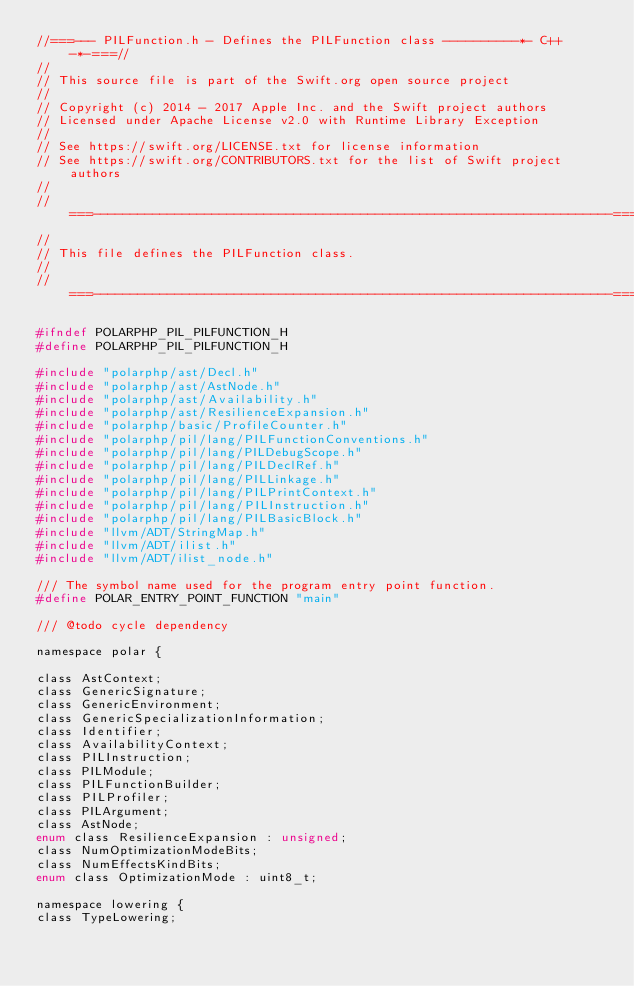<code> <loc_0><loc_0><loc_500><loc_500><_C_>//===--- PILFunction.h - Defines the PILFunction class ----------*- C++ -*-===//
//
// This source file is part of the Swift.org open source project
//
// Copyright (c) 2014 - 2017 Apple Inc. and the Swift project authors
// Licensed under Apache License v2.0 with Runtime Library Exception
//
// See https://swift.org/LICENSE.txt for license information
// See https://swift.org/CONTRIBUTORS.txt for the list of Swift project authors
//
//===----------------------------------------------------------------------===//
//
// This file defines the PILFunction class.
//
//===----------------------------------------------------------------------===//

#ifndef POLARPHP_PIL_PILFUNCTION_H
#define POLARPHP_PIL_PILFUNCTION_H

#include "polarphp/ast/Decl.h"
#include "polarphp/ast/AstNode.h"
#include "polarphp/ast/Availability.h"
#include "polarphp/ast/ResilienceExpansion.h"
#include "polarphp/basic/ProfileCounter.h"
#include "polarphp/pil/lang/PILFunctionConventions.h"
#include "polarphp/pil/lang/PILDebugScope.h"
#include "polarphp/pil/lang/PILDeclRef.h"
#include "polarphp/pil/lang/PILLinkage.h"
#include "polarphp/pil/lang/PILPrintContext.h"
#include "polarphp/pil/lang/PILInstruction.h"
#include "polarphp/pil/lang/PILBasicBlock.h"
#include "llvm/ADT/StringMap.h"
#include "llvm/ADT/ilist.h"
#include "llvm/ADT/ilist_node.h"

/// The symbol name used for the program entry point function.
#define POLAR_ENTRY_POINT_FUNCTION "main"

/// @todo cycle dependency

namespace polar {

class AstContext;
class GenericSignature;
class GenericEnvironment;
class GenericSpecializationInformation;
class Identifier;
class AvailabilityContext;
class PILInstruction;
class PILModule;
class PILFunctionBuilder;
class PILProfiler;
class PILArgument;
class AstNode;
enum class ResilienceExpansion : unsigned;
class NumOptimizationModeBits;
class NumEffectsKindBits;
enum class OptimizationMode : uint8_t;

namespace lowering {
class TypeLowering;</code> 